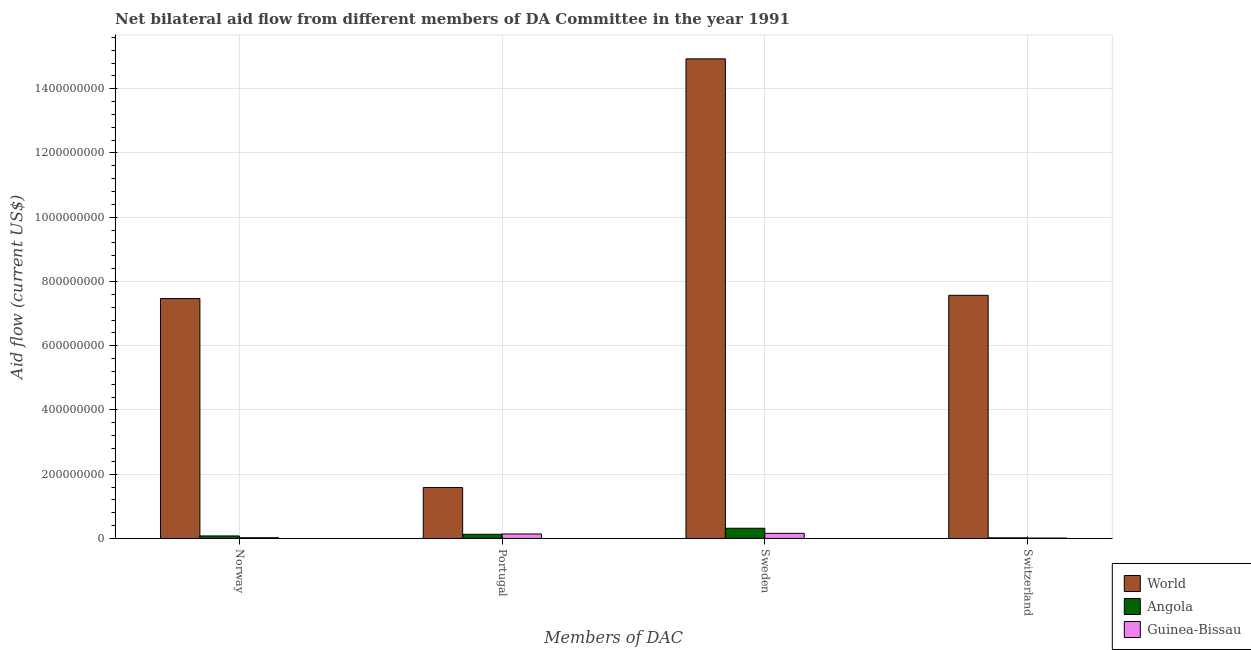How many different coloured bars are there?
Provide a short and direct response. 3. How many groups of bars are there?
Give a very brief answer. 4. Are the number of bars per tick equal to the number of legend labels?
Ensure brevity in your answer.  Yes. Are the number of bars on each tick of the X-axis equal?
Make the answer very short. Yes. How many bars are there on the 3rd tick from the right?
Provide a succinct answer. 3. What is the amount of aid given by sweden in Guinea-Bissau?
Make the answer very short. 1.59e+07. Across all countries, what is the maximum amount of aid given by norway?
Make the answer very short. 7.47e+08. Across all countries, what is the minimum amount of aid given by sweden?
Offer a very short reply. 1.59e+07. In which country was the amount of aid given by portugal maximum?
Make the answer very short. World. In which country was the amount of aid given by switzerland minimum?
Your answer should be very brief. Guinea-Bissau. What is the total amount of aid given by portugal in the graph?
Give a very brief answer. 1.85e+08. What is the difference between the amount of aid given by switzerland in Guinea-Bissau and that in Angola?
Your answer should be compact. -7.00e+05. What is the difference between the amount of aid given by switzerland in World and the amount of aid given by norway in Guinea-Bissau?
Provide a short and direct response. 7.54e+08. What is the average amount of aid given by portugal per country?
Your response must be concise. 6.17e+07. What is the difference between the amount of aid given by norway and amount of aid given by sweden in Guinea-Bissau?
Offer a terse response. -1.36e+07. What is the ratio of the amount of aid given by sweden in World to that in Guinea-Bissau?
Your response must be concise. 94.08. What is the difference between the highest and the second highest amount of aid given by sweden?
Give a very brief answer. 1.46e+09. What is the difference between the highest and the lowest amount of aid given by sweden?
Keep it short and to the point. 1.48e+09. In how many countries, is the amount of aid given by norway greater than the average amount of aid given by norway taken over all countries?
Your answer should be very brief. 1. Is it the case that in every country, the sum of the amount of aid given by norway and amount of aid given by portugal is greater than the sum of amount of aid given by switzerland and amount of aid given by sweden?
Provide a short and direct response. No. What does the 3rd bar from the left in Norway represents?
Offer a terse response. Guinea-Bissau. Are all the bars in the graph horizontal?
Provide a short and direct response. No. How many countries are there in the graph?
Provide a succinct answer. 3. What is the difference between two consecutive major ticks on the Y-axis?
Provide a succinct answer. 2.00e+08. Does the graph contain any zero values?
Your answer should be compact. No. Does the graph contain grids?
Your answer should be compact. Yes. Where does the legend appear in the graph?
Offer a terse response. Bottom right. How many legend labels are there?
Offer a very short reply. 3. What is the title of the graph?
Your answer should be compact. Net bilateral aid flow from different members of DA Committee in the year 1991. Does "Channel Islands" appear as one of the legend labels in the graph?
Make the answer very short. No. What is the label or title of the X-axis?
Your answer should be compact. Members of DAC. What is the Aid flow (current US$) in World in Norway?
Give a very brief answer. 7.47e+08. What is the Aid flow (current US$) in Angola in Norway?
Provide a succinct answer. 7.80e+06. What is the Aid flow (current US$) in Guinea-Bissau in Norway?
Provide a short and direct response. 2.31e+06. What is the Aid flow (current US$) of World in Portugal?
Provide a succinct answer. 1.58e+08. What is the Aid flow (current US$) of Angola in Portugal?
Your answer should be very brief. 1.29e+07. What is the Aid flow (current US$) of Guinea-Bissau in Portugal?
Make the answer very short. 1.39e+07. What is the Aid flow (current US$) of World in Sweden?
Make the answer very short. 1.49e+09. What is the Aid flow (current US$) of Angola in Sweden?
Give a very brief answer. 3.17e+07. What is the Aid flow (current US$) of Guinea-Bissau in Sweden?
Ensure brevity in your answer.  1.59e+07. What is the Aid flow (current US$) of World in Switzerland?
Ensure brevity in your answer.  7.57e+08. What is the Aid flow (current US$) in Angola in Switzerland?
Keep it short and to the point. 1.85e+06. What is the Aid flow (current US$) in Guinea-Bissau in Switzerland?
Your answer should be very brief. 1.15e+06. Across all Members of DAC, what is the maximum Aid flow (current US$) in World?
Keep it short and to the point. 1.49e+09. Across all Members of DAC, what is the maximum Aid flow (current US$) of Angola?
Provide a short and direct response. 3.17e+07. Across all Members of DAC, what is the maximum Aid flow (current US$) of Guinea-Bissau?
Give a very brief answer. 1.59e+07. Across all Members of DAC, what is the minimum Aid flow (current US$) in World?
Keep it short and to the point. 1.58e+08. Across all Members of DAC, what is the minimum Aid flow (current US$) in Angola?
Your answer should be very brief. 1.85e+06. Across all Members of DAC, what is the minimum Aid flow (current US$) in Guinea-Bissau?
Ensure brevity in your answer.  1.15e+06. What is the total Aid flow (current US$) of World in the graph?
Your response must be concise. 3.15e+09. What is the total Aid flow (current US$) in Angola in the graph?
Your response must be concise. 5.43e+07. What is the total Aid flow (current US$) in Guinea-Bissau in the graph?
Your answer should be compact. 3.32e+07. What is the difference between the Aid flow (current US$) of World in Norway and that in Portugal?
Your response must be concise. 5.88e+08. What is the difference between the Aid flow (current US$) in Angola in Norway and that in Portugal?
Keep it short and to the point. -5.13e+06. What is the difference between the Aid flow (current US$) in Guinea-Bissau in Norway and that in Portugal?
Your answer should be very brief. -1.16e+07. What is the difference between the Aid flow (current US$) of World in Norway and that in Sweden?
Make the answer very short. -7.46e+08. What is the difference between the Aid flow (current US$) of Angola in Norway and that in Sweden?
Keep it short and to the point. -2.39e+07. What is the difference between the Aid flow (current US$) in Guinea-Bissau in Norway and that in Sweden?
Provide a short and direct response. -1.36e+07. What is the difference between the Aid flow (current US$) of World in Norway and that in Switzerland?
Offer a very short reply. -1.01e+07. What is the difference between the Aid flow (current US$) in Angola in Norway and that in Switzerland?
Make the answer very short. 5.95e+06. What is the difference between the Aid flow (current US$) of Guinea-Bissau in Norway and that in Switzerland?
Your answer should be very brief. 1.16e+06. What is the difference between the Aid flow (current US$) in World in Portugal and that in Sweden?
Offer a terse response. -1.33e+09. What is the difference between the Aid flow (current US$) in Angola in Portugal and that in Sweden?
Your answer should be very brief. -1.88e+07. What is the difference between the Aid flow (current US$) of Guinea-Bissau in Portugal and that in Sweden?
Ensure brevity in your answer.  -2.01e+06. What is the difference between the Aid flow (current US$) of World in Portugal and that in Switzerland?
Keep it short and to the point. -5.98e+08. What is the difference between the Aid flow (current US$) in Angola in Portugal and that in Switzerland?
Keep it short and to the point. 1.11e+07. What is the difference between the Aid flow (current US$) in Guinea-Bissau in Portugal and that in Switzerland?
Make the answer very short. 1.27e+07. What is the difference between the Aid flow (current US$) of World in Sweden and that in Switzerland?
Your answer should be compact. 7.36e+08. What is the difference between the Aid flow (current US$) of Angola in Sweden and that in Switzerland?
Your answer should be compact. 2.99e+07. What is the difference between the Aid flow (current US$) in Guinea-Bissau in Sweden and that in Switzerland?
Provide a short and direct response. 1.47e+07. What is the difference between the Aid flow (current US$) of World in Norway and the Aid flow (current US$) of Angola in Portugal?
Offer a very short reply. 7.34e+08. What is the difference between the Aid flow (current US$) in World in Norway and the Aid flow (current US$) in Guinea-Bissau in Portugal?
Make the answer very short. 7.33e+08. What is the difference between the Aid flow (current US$) in Angola in Norway and the Aid flow (current US$) in Guinea-Bissau in Portugal?
Your answer should be compact. -6.06e+06. What is the difference between the Aid flow (current US$) in World in Norway and the Aid flow (current US$) in Angola in Sweden?
Your answer should be very brief. 7.15e+08. What is the difference between the Aid flow (current US$) of World in Norway and the Aid flow (current US$) of Guinea-Bissau in Sweden?
Offer a terse response. 7.31e+08. What is the difference between the Aid flow (current US$) in Angola in Norway and the Aid flow (current US$) in Guinea-Bissau in Sweden?
Keep it short and to the point. -8.07e+06. What is the difference between the Aid flow (current US$) of World in Norway and the Aid flow (current US$) of Angola in Switzerland?
Give a very brief answer. 7.45e+08. What is the difference between the Aid flow (current US$) of World in Norway and the Aid flow (current US$) of Guinea-Bissau in Switzerland?
Your response must be concise. 7.46e+08. What is the difference between the Aid flow (current US$) of Angola in Norway and the Aid flow (current US$) of Guinea-Bissau in Switzerland?
Provide a succinct answer. 6.65e+06. What is the difference between the Aid flow (current US$) of World in Portugal and the Aid flow (current US$) of Angola in Sweden?
Give a very brief answer. 1.27e+08. What is the difference between the Aid flow (current US$) in World in Portugal and the Aid flow (current US$) in Guinea-Bissau in Sweden?
Give a very brief answer. 1.43e+08. What is the difference between the Aid flow (current US$) in Angola in Portugal and the Aid flow (current US$) in Guinea-Bissau in Sweden?
Your answer should be compact. -2.94e+06. What is the difference between the Aid flow (current US$) of World in Portugal and the Aid flow (current US$) of Angola in Switzerland?
Ensure brevity in your answer.  1.57e+08. What is the difference between the Aid flow (current US$) of World in Portugal and the Aid flow (current US$) of Guinea-Bissau in Switzerland?
Your answer should be very brief. 1.57e+08. What is the difference between the Aid flow (current US$) in Angola in Portugal and the Aid flow (current US$) in Guinea-Bissau in Switzerland?
Provide a succinct answer. 1.18e+07. What is the difference between the Aid flow (current US$) of World in Sweden and the Aid flow (current US$) of Angola in Switzerland?
Keep it short and to the point. 1.49e+09. What is the difference between the Aid flow (current US$) in World in Sweden and the Aid flow (current US$) in Guinea-Bissau in Switzerland?
Your answer should be very brief. 1.49e+09. What is the difference between the Aid flow (current US$) in Angola in Sweden and the Aid flow (current US$) in Guinea-Bissau in Switzerland?
Your answer should be compact. 3.06e+07. What is the average Aid flow (current US$) of World per Members of DAC?
Offer a terse response. 7.89e+08. What is the average Aid flow (current US$) in Angola per Members of DAC?
Your answer should be compact. 1.36e+07. What is the average Aid flow (current US$) in Guinea-Bissau per Members of DAC?
Ensure brevity in your answer.  8.30e+06. What is the difference between the Aid flow (current US$) of World and Aid flow (current US$) of Angola in Norway?
Offer a very short reply. 7.39e+08. What is the difference between the Aid flow (current US$) in World and Aid flow (current US$) in Guinea-Bissau in Norway?
Provide a short and direct response. 7.44e+08. What is the difference between the Aid flow (current US$) of Angola and Aid flow (current US$) of Guinea-Bissau in Norway?
Your answer should be compact. 5.49e+06. What is the difference between the Aid flow (current US$) of World and Aid flow (current US$) of Angola in Portugal?
Provide a short and direct response. 1.45e+08. What is the difference between the Aid flow (current US$) in World and Aid flow (current US$) in Guinea-Bissau in Portugal?
Your response must be concise. 1.45e+08. What is the difference between the Aid flow (current US$) in Angola and Aid flow (current US$) in Guinea-Bissau in Portugal?
Ensure brevity in your answer.  -9.30e+05. What is the difference between the Aid flow (current US$) of World and Aid flow (current US$) of Angola in Sweden?
Make the answer very short. 1.46e+09. What is the difference between the Aid flow (current US$) in World and Aid flow (current US$) in Guinea-Bissau in Sweden?
Offer a terse response. 1.48e+09. What is the difference between the Aid flow (current US$) of Angola and Aid flow (current US$) of Guinea-Bissau in Sweden?
Provide a short and direct response. 1.58e+07. What is the difference between the Aid flow (current US$) of World and Aid flow (current US$) of Angola in Switzerland?
Your answer should be very brief. 7.55e+08. What is the difference between the Aid flow (current US$) of World and Aid flow (current US$) of Guinea-Bissau in Switzerland?
Offer a very short reply. 7.56e+08. What is the ratio of the Aid flow (current US$) of World in Norway to that in Portugal?
Offer a very short reply. 4.71. What is the ratio of the Aid flow (current US$) in Angola in Norway to that in Portugal?
Provide a succinct answer. 0.6. What is the ratio of the Aid flow (current US$) of World in Norway to that in Sweden?
Offer a very short reply. 0.5. What is the ratio of the Aid flow (current US$) in Angola in Norway to that in Sweden?
Ensure brevity in your answer.  0.25. What is the ratio of the Aid flow (current US$) in Guinea-Bissau in Norway to that in Sweden?
Provide a succinct answer. 0.15. What is the ratio of the Aid flow (current US$) of World in Norway to that in Switzerland?
Give a very brief answer. 0.99. What is the ratio of the Aid flow (current US$) of Angola in Norway to that in Switzerland?
Offer a very short reply. 4.22. What is the ratio of the Aid flow (current US$) in Guinea-Bissau in Norway to that in Switzerland?
Your response must be concise. 2.01. What is the ratio of the Aid flow (current US$) in World in Portugal to that in Sweden?
Provide a succinct answer. 0.11. What is the ratio of the Aid flow (current US$) in Angola in Portugal to that in Sweden?
Give a very brief answer. 0.41. What is the ratio of the Aid flow (current US$) in Guinea-Bissau in Portugal to that in Sweden?
Your answer should be compact. 0.87. What is the ratio of the Aid flow (current US$) in World in Portugal to that in Switzerland?
Offer a very short reply. 0.21. What is the ratio of the Aid flow (current US$) of Angola in Portugal to that in Switzerland?
Keep it short and to the point. 6.99. What is the ratio of the Aid flow (current US$) in Guinea-Bissau in Portugal to that in Switzerland?
Your answer should be very brief. 12.05. What is the ratio of the Aid flow (current US$) of World in Sweden to that in Switzerland?
Your answer should be very brief. 1.97. What is the ratio of the Aid flow (current US$) of Angola in Sweden to that in Switzerland?
Your response must be concise. 17.15. What is the difference between the highest and the second highest Aid flow (current US$) in World?
Provide a succinct answer. 7.36e+08. What is the difference between the highest and the second highest Aid flow (current US$) of Angola?
Offer a very short reply. 1.88e+07. What is the difference between the highest and the second highest Aid flow (current US$) in Guinea-Bissau?
Offer a terse response. 2.01e+06. What is the difference between the highest and the lowest Aid flow (current US$) of World?
Keep it short and to the point. 1.33e+09. What is the difference between the highest and the lowest Aid flow (current US$) of Angola?
Make the answer very short. 2.99e+07. What is the difference between the highest and the lowest Aid flow (current US$) in Guinea-Bissau?
Provide a succinct answer. 1.47e+07. 